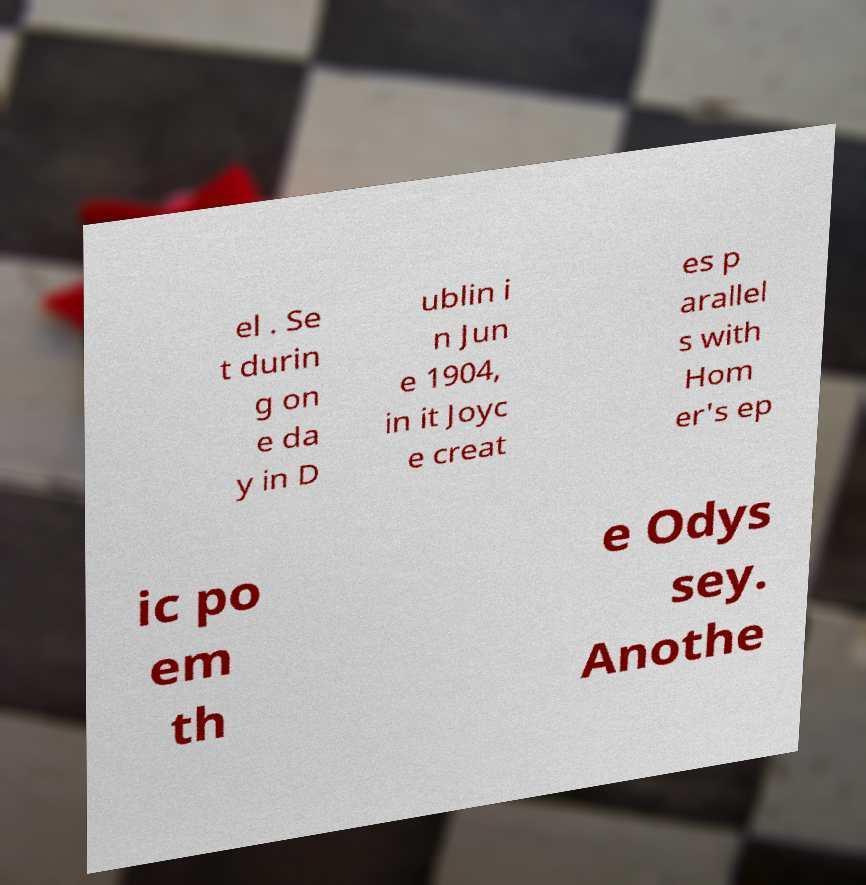Can you read and provide the text displayed in the image?This photo seems to have some interesting text. Can you extract and type it out for me? el . Se t durin g on e da y in D ublin i n Jun e 1904, in it Joyc e creat es p arallel s with Hom er's ep ic po em th e Odys sey. Anothe 